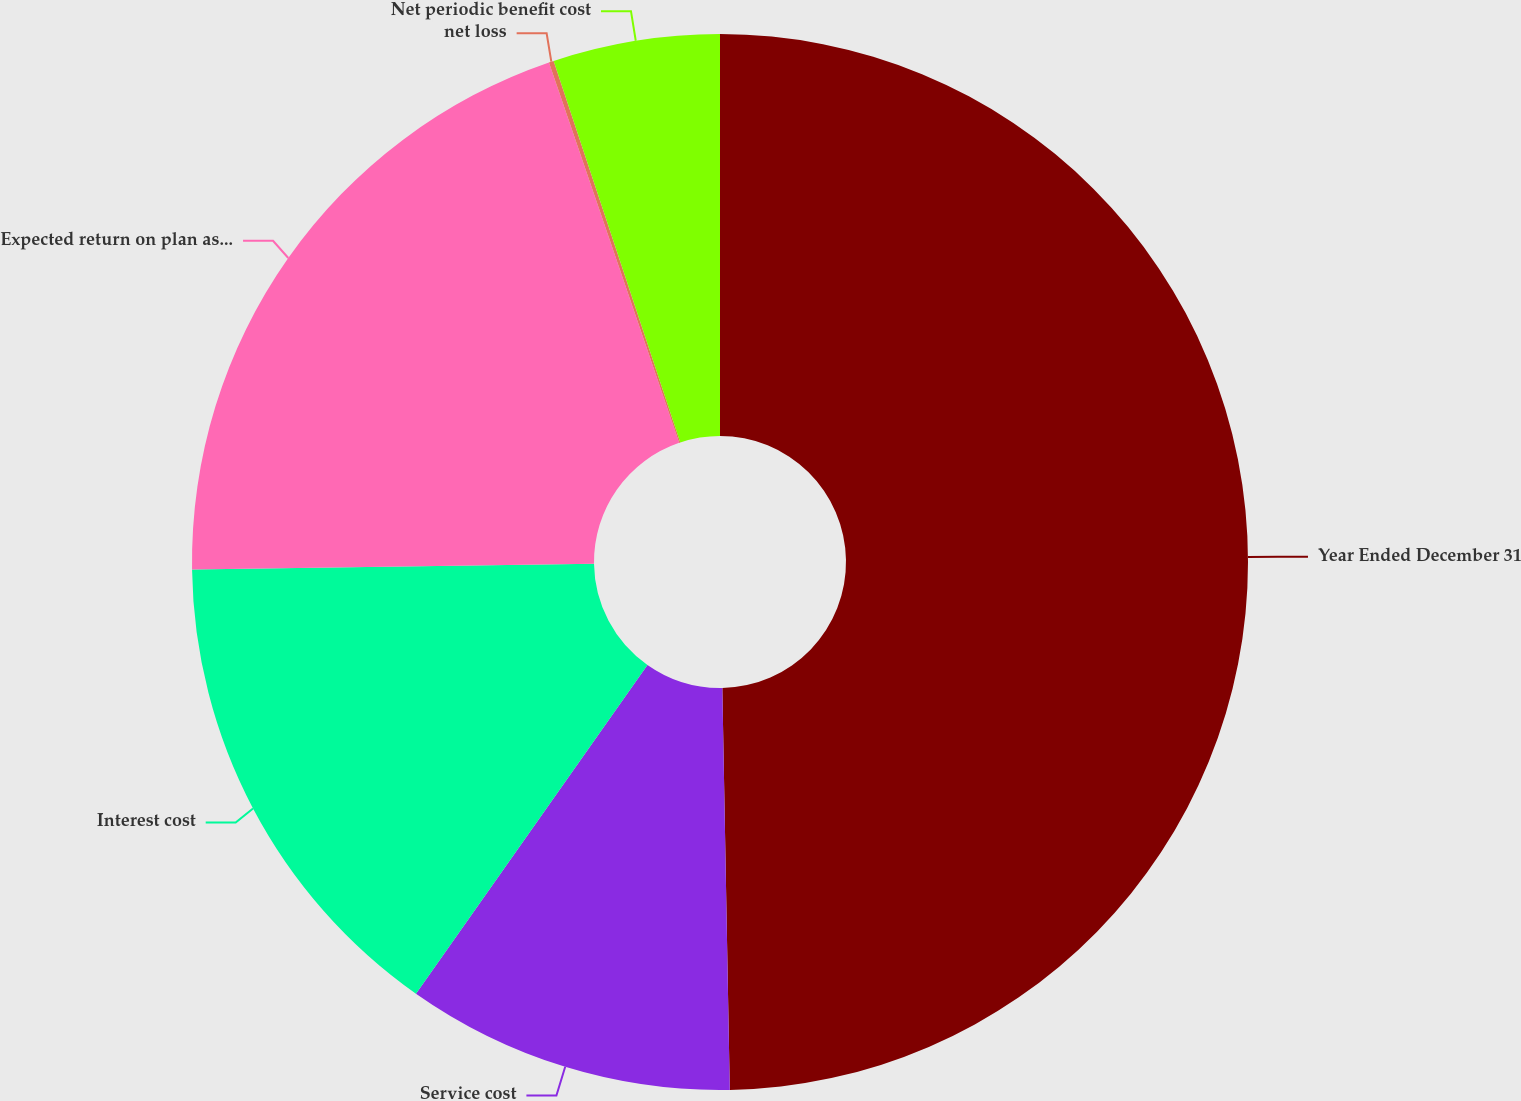Convert chart. <chart><loc_0><loc_0><loc_500><loc_500><pie_chart><fcel>Year Ended December 31<fcel>Service cost<fcel>Interest cost<fcel>Expected return on plan assets<fcel>net loss<fcel>Net periodic benefit cost<nl><fcel>49.7%<fcel>10.06%<fcel>15.01%<fcel>19.97%<fcel>0.15%<fcel>5.1%<nl></chart> 